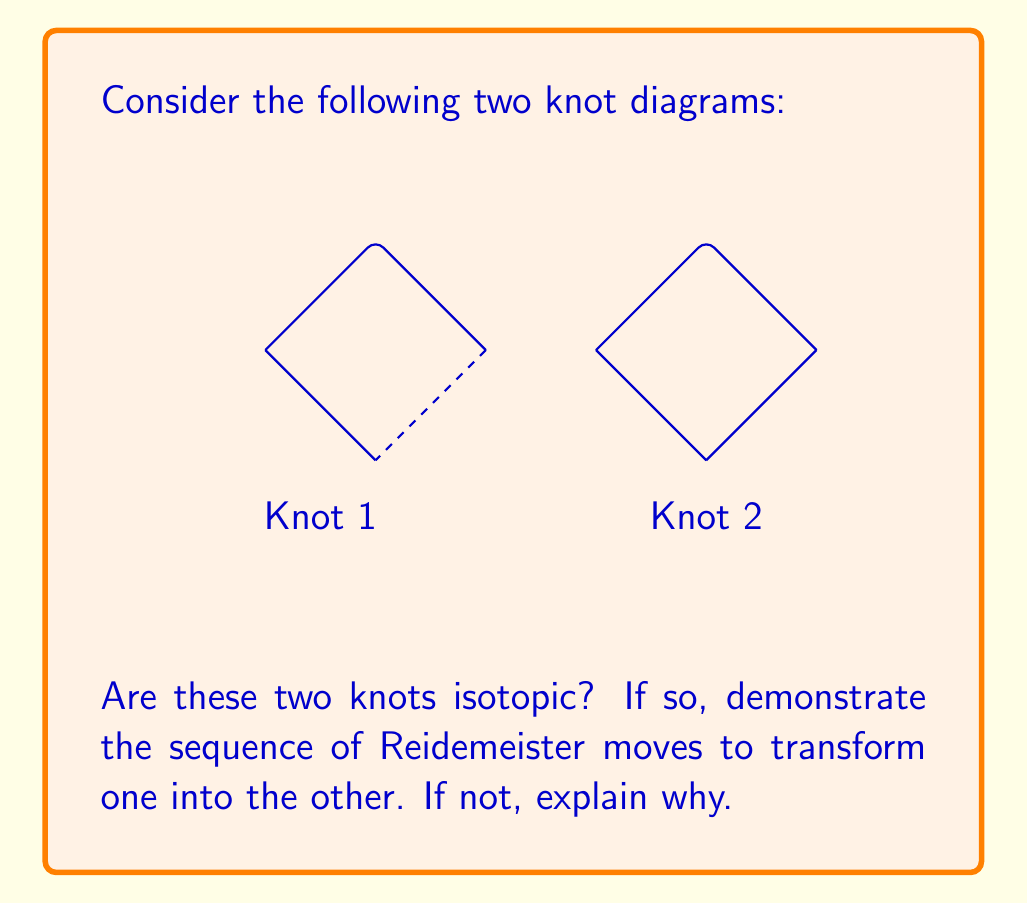Could you help me with this problem? Let's approach this step-by-step:

1) First, we need to recall the three types of Reidemeister moves:
   - Type I: Adding or removing a twist
   - Type II: Moving one strand completely over or under another
   - Type III: Moving a strand over or under a crossing

2) Looking at Knot 1, we can see it's the unknot (trivial knot) with an extra twist.

3) To simplify Knot 1:
   - Apply a Type I move to remove the twist.
   
   [asy]
   import knots;
   size(100);
   draw((0,2)--(2,0)--(0,-2)--(-2,0)--(0,2));
   [/asy]

4) Now Knot 1 is clearly the unknot (a simple loop).

5) Looking at Knot 2, we can see it's already in the form of the unknot.

6) Since both knots can be reduced to the unknot, they are isotopic.

7) The sequence of moves to transform Knot 1 into Knot 2:
   - Apply Type I move to Knot 1 to remove the twist
   - The resulting unknot is equivalent to Knot 2

Therefore, the two knots are indeed isotopic.
Answer: Yes, isotopic. One Type I move. 